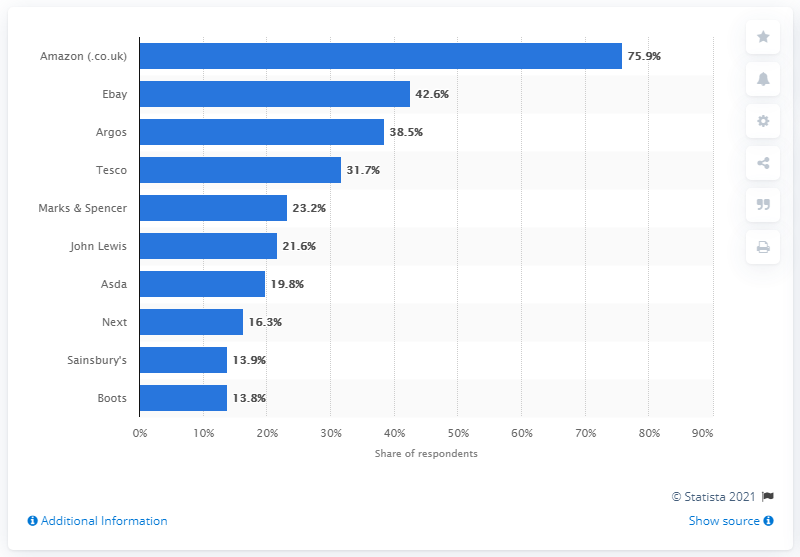List a handful of essential elements in this visual. Argos was the third most popular online retailer in the UK in 2014. 